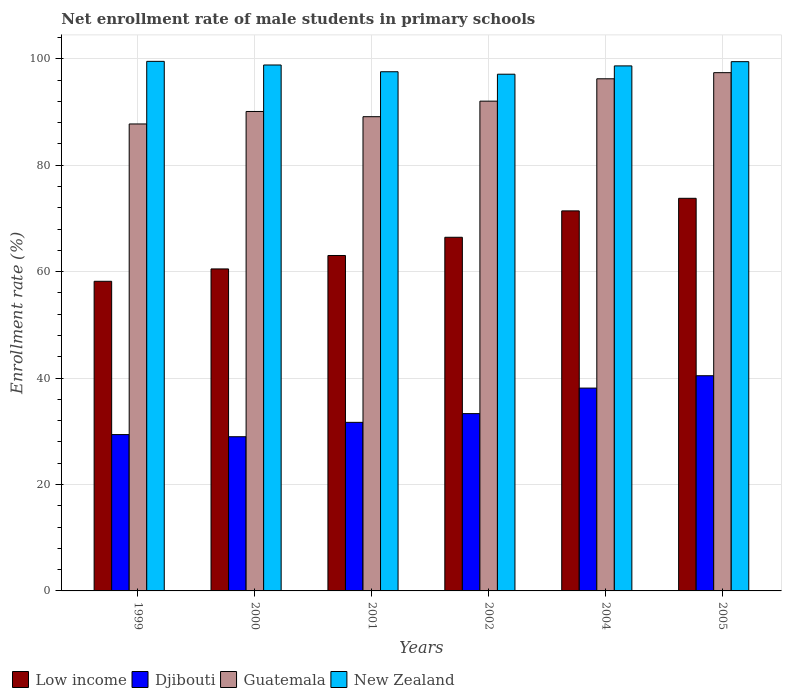How many bars are there on the 2nd tick from the right?
Give a very brief answer. 4. In how many cases, is the number of bars for a given year not equal to the number of legend labels?
Your answer should be very brief. 0. What is the net enrollment rate of male students in primary schools in Guatemala in 1999?
Your answer should be very brief. 87.76. Across all years, what is the maximum net enrollment rate of male students in primary schools in Guatemala?
Offer a terse response. 97.4. Across all years, what is the minimum net enrollment rate of male students in primary schools in Low income?
Provide a short and direct response. 58.19. In which year was the net enrollment rate of male students in primary schools in Low income minimum?
Your response must be concise. 1999. What is the total net enrollment rate of male students in primary schools in Guatemala in the graph?
Provide a succinct answer. 552.7. What is the difference between the net enrollment rate of male students in primary schools in Low income in 1999 and that in 2001?
Your answer should be compact. -4.85. What is the difference between the net enrollment rate of male students in primary schools in Guatemala in 2001 and the net enrollment rate of male students in primary schools in Low income in 2004?
Your answer should be compact. 17.7. What is the average net enrollment rate of male students in primary schools in Djibouti per year?
Offer a terse response. 33.66. In the year 2005, what is the difference between the net enrollment rate of male students in primary schools in Low income and net enrollment rate of male students in primary schools in Guatemala?
Offer a very short reply. -23.61. In how many years, is the net enrollment rate of male students in primary schools in New Zealand greater than 8 %?
Provide a short and direct response. 6. What is the ratio of the net enrollment rate of male students in primary schools in Guatemala in 2000 to that in 2001?
Your response must be concise. 1.01. What is the difference between the highest and the second highest net enrollment rate of male students in primary schools in New Zealand?
Make the answer very short. 0.06. What is the difference between the highest and the lowest net enrollment rate of male students in primary schools in Low income?
Your answer should be very brief. 15.6. Is it the case that in every year, the sum of the net enrollment rate of male students in primary schools in Guatemala and net enrollment rate of male students in primary schools in Djibouti is greater than the sum of net enrollment rate of male students in primary schools in New Zealand and net enrollment rate of male students in primary schools in Low income?
Offer a terse response. No. What does the 3rd bar from the left in 2001 represents?
Keep it short and to the point. Guatemala. Are the values on the major ticks of Y-axis written in scientific E-notation?
Keep it short and to the point. No. Does the graph contain any zero values?
Offer a very short reply. No. Does the graph contain grids?
Provide a short and direct response. Yes. What is the title of the graph?
Provide a short and direct response. Net enrollment rate of male students in primary schools. Does "Somalia" appear as one of the legend labels in the graph?
Keep it short and to the point. No. What is the label or title of the Y-axis?
Your answer should be very brief. Enrollment rate (%). What is the Enrollment rate (%) in Low income in 1999?
Your answer should be compact. 58.19. What is the Enrollment rate (%) of Djibouti in 1999?
Offer a terse response. 29.38. What is the Enrollment rate (%) of Guatemala in 1999?
Ensure brevity in your answer.  87.76. What is the Enrollment rate (%) in New Zealand in 1999?
Provide a succinct answer. 99.53. What is the Enrollment rate (%) in Low income in 2000?
Make the answer very short. 60.52. What is the Enrollment rate (%) in Djibouti in 2000?
Your answer should be compact. 28.98. What is the Enrollment rate (%) of Guatemala in 2000?
Your answer should be very brief. 90.11. What is the Enrollment rate (%) of New Zealand in 2000?
Your answer should be very brief. 98.85. What is the Enrollment rate (%) of Low income in 2001?
Offer a terse response. 63.04. What is the Enrollment rate (%) in Djibouti in 2001?
Provide a short and direct response. 31.68. What is the Enrollment rate (%) of Guatemala in 2001?
Offer a terse response. 89.13. What is the Enrollment rate (%) of New Zealand in 2001?
Provide a succinct answer. 97.58. What is the Enrollment rate (%) in Low income in 2002?
Provide a succinct answer. 66.46. What is the Enrollment rate (%) of Djibouti in 2002?
Your answer should be very brief. 33.32. What is the Enrollment rate (%) of Guatemala in 2002?
Keep it short and to the point. 92.05. What is the Enrollment rate (%) in New Zealand in 2002?
Your answer should be compact. 97.11. What is the Enrollment rate (%) in Low income in 2004?
Provide a succinct answer. 71.43. What is the Enrollment rate (%) of Djibouti in 2004?
Keep it short and to the point. 38.12. What is the Enrollment rate (%) in Guatemala in 2004?
Your answer should be very brief. 96.25. What is the Enrollment rate (%) of New Zealand in 2004?
Ensure brevity in your answer.  98.68. What is the Enrollment rate (%) of Low income in 2005?
Make the answer very short. 73.79. What is the Enrollment rate (%) in Djibouti in 2005?
Keep it short and to the point. 40.44. What is the Enrollment rate (%) in Guatemala in 2005?
Provide a succinct answer. 97.4. What is the Enrollment rate (%) of New Zealand in 2005?
Make the answer very short. 99.47. Across all years, what is the maximum Enrollment rate (%) of Low income?
Keep it short and to the point. 73.79. Across all years, what is the maximum Enrollment rate (%) of Djibouti?
Make the answer very short. 40.44. Across all years, what is the maximum Enrollment rate (%) in Guatemala?
Your response must be concise. 97.4. Across all years, what is the maximum Enrollment rate (%) in New Zealand?
Your response must be concise. 99.53. Across all years, what is the minimum Enrollment rate (%) in Low income?
Give a very brief answer. 58.19. Across all years, what is the minimum Enrollment rate (%) of Djibouti?
Your answer should be compact. 28.98. Across all years, what is the minimum Enrollment rate (%) of Guatemala?
Give a very brief answer. 87.76. Across all years, what is the minimum Enrollment rate (%) of New Zealand?
Your answer should be compact. 97.11. What is the total Enrollment rate (%) in Low income in the graph?
Offer a very short reply. 393.43. What is the total Enrollment rate (%) of Djibouti in the graph?
Your answer should be compact. 201.93. What is the total Enrollment rate (%) of Guatemala in the graph?
Your response must be concise. 552.7. What is the total Enrollment rate (%) in New Zealand in the graph?
Give a very brief answer. 591.2. What is the difference between the Enrollment rate (%) in Low income in 1999 and that in 2000?
Offer a terse response. -2.32. What is the difference between the Enrollment rate (%) in Djibouti in 1999 and that in 2000?
Provide a short and direct response. 0.4. What is the difference between the Enrollment rate (%) in Guatemala in 1999 and that in 2000?
Make the answer very short. -2.35. What is the difference between the Enrollment rate (%) in New Zealand in 1999 and that in 2000?
Ensure brevity in your answer.  0.68. What is the difference between the Enrollment rate (%) of Low income in 1999 and that in 2001?
Make the answer very short. -4.85. What is the difference between the Enrollment rate (%) in Djibouti in 1999 and that in 2001?
Provide a short and direct response. -2.3. What is the difference between the Enrollment rate (%) in Guatemala in 1999 and that in 2001?
Make the answer very short. -1.37. What is the difference between the Enrollment rate (%) in New Zealand in 1999 and that in 2001?
Your answer should be very brief. 1.95. What is the difference between the Enrollment rate (%) of Low income in 1999 and that in 2002?
Ensure brevity in your answer.  -8.27. What is the difference between the Enrollment rate (%) in Djibouti in 1999 and that in 2002?
Keep it short and to the point. -3.94. What is the difference between the Enrollment rate (%) in Guatemala in 1999 and that in 2002?
Make the answer very short. -4.29. What is the difference between the Enrollment rate (%) in New Zealand in 1999 and that in 2002?
Your response must be concise. 2.42. What is the difference between the Enrollment rate (%) of Low income in 1999 and that in 2004?
Your response must be concise. -13.23. What is the difference between the Enrollment rate (%) in Djibouti in 1999 and that in 2004?
Provide a short and direct response. -8.74. What is the difference between the Enrollment rate (%) of Guatemala in 1999 and that in 2004?
Keep it short and to the point. -8.49. What is the difference between the Enrollment rate (%) of New Zealand in 1999 and that in 2004?
Ensure brevity in your answer.  0.85. What is the difference between the Enrollment rate (%) of Low income in 1999 and that in 2005?
Your answer should be compact. -15.6. What is the difference between the Enrollment rate (%) of Djibouti in 1999 and that in 2005?
Give a very brief answer. -11.06. What is the difference between the Enrollment rate (%) in Guatemala in 1999 and that in 2005?
Your response must be concise. -9.64. What is the difference between the Enrollment rate (%) of New Zealand in 1999 and that in 2005?
Provide a short and direct response. 0.06. What is the difference between the Enrollment rate (%) in Low income in 2000 and that in 2001?
Provide a short and direct response. -2.53. What is the difference between the Enrollment rate (%) of Djibouti in 2000 and that in 2001?
Ensure brevity in your answer.  -2.7. What is the difference between the Enrollment rate (%) of Guatemala in 2000 and that in 2001?
Your response must be concise. 0.98. What is the difference between the Enrollment rate (%) in New Zealand in 2000 and that in 2001?
Keep it short and to the point. 1.27. What is the difference between the Enrollment rate (%) in Low income in 2000 and that in 2002?
Offer a terse response. -5.95. What is the difference between the Enrollment rate (%) of Djibouti in 2000 and that in 2002?
Offer a terse response. -4.34. What is the difference between the Enrollment rate (%) in Guatemala in 2000 and that in 2002?
Keep it short and to the point. -1.94. What is the difference between the Enrollment rate (%) of New Zealand in 2000 and that in 2002?
Give a very brief answer. 1.74. What is the difference between the Enrollment rate (%) of Low income in 2000 and that in 2004?
Ensure brevity in your answer.  -10.91. What is the difference between the Enrollment rate (%) of Djibouti in 2000 and that in 2004?
Provide a succinct answer. -9.14. What is the difference between the Enrollment rate (%) of Guatemala in 2000 and that in 2004?
Keep it short and to the point. -6.14. What is the difference between the Enrollment rate (%) of New Zealand in 2000 and that in 2004?
Offer a terse response. 0.17. What is the difference between the Enrollment rate (%) in Low income in 2000 and that in 2005?
Keep it short and to the point. -13.27. What is the difference between the Enrollment rate (%) of Djibouti in 2000 and that in 2005?
Offer a very short reply. -11.46. What is the difference between the Enrollment rate (%) in Guatemala in 2000 and that in 2005?
Make the answer very short. -7.3. What is the difference between the Enrollment rate (%) of New Zealand in 2000 and that in 2005?
Provide a succinct answer. -0.62. What is the difference between the Enrollment rate (%) in Low income in 2001 and that in 2002?
Your answer should be very brief. -3.42. What is the difference between the Enrollment rate (%) in Djibouti in 2001 and that in 2002?
Your answer should be compact. -1.64. What is the difference between the Enrollment rate (%) in Guatemala in 2001 and that in 2002?
Keep it short and to the point. -2.92. What is the difference between the Enrollment rate (%) of New Zealand in 2001 and that in 2002?
Offer a very short reply. 0.46. What is the difference between the Enrollment rate (%) in Low income in 2001 and that in 2004?
Make the answer very short. -8.38. What is the difference between the Enrollment rate (%) in Djibouti in 2001 and that in 2004?
Ensure brevity in your answer.  -6.44. What is the difference between the Enrollment rate (%) of Guatemala in 2001 and that in 2004?
Offer a terse response. -7.12. What is the difference between the Enrollment rate (%) in New Zealand in 2001 and that in 2004?
Your answer should be compact. -1.1. What is the difference between the Enrollment rate (%) of Low income in 2001 and that in 2005?
Make the answer very short. -10.75. What is the difference between the Enrollment rate (%) in Djibouti in 2001 and that in 2005?
Your answer should be very brief. -8.76. What is the difference between the Enrollment rate (%) in Guatemala in 2001 and that in 2005?
Make the answer very short. -8.27. What is the difference between the Enrollment rate (%) of New Zealand in 2001 and that in 2005?
Ensure brevity in your answer.  -1.89. What is the difference between the Enrollment rate (%) in Low income in 2002 and that in 2004?
Provide a succinct answer. -4.96. What is the difference between the Enrollment rate (%) in Djibouti in 2002 and that in 2004?
Give a very brief answer. -4.8. What is the difference between the Enrollment rate (%) in Guatemala in 2002 and that in 2004?
Offer a terse response. -4.2. What is the difference between the Enrollment rate (%) of New Zealand in 2002 and that in 2004?
Ensure brevity in your answer.  -1.56. What is the difference between the Enrollment rate (%) of Low income in 2002 and that in 2005?
Give a very brief answer. -7.33. What is the difference between the Enrollment rate (%) of Djibouti in 2002 and that in 2005?
Provide a succinct answer. -7.12. What is the difference between the Enrollment rate (%) in Guatemala in 2002 and that in 2005?
Make the answer very short. -5.35. What is the difference between the Enrollment rate (%) of New Zealand in 2002 and that in 2005?
Ensure brevity in your answer.  -2.36. What is the difference between the Enrollment rate (%) of Low income in 2004 and that in 2005?
Your answer should be compact. -2.37. What is the difference between the Enrollment rate (%) in Djibouti in 2004 and that in 2005?
Offer a terse response. -2.32. What is the difference between the Enrollment rate (%) of Guatemala in 2004 and that in 2005?
Your response must be concise. -1.15. What is the difference between the Enrollment rate (%) in New Zealand in 2004 and that in 2005?
Provide a succinct answer. -0.79. What is the difference between the Enrollment rate (%) in Low income in 1999 and the Enrollment rate (%) in Djibouti in 2000?
Ensure brevity in your answer.  29.21. What is the difference between the Enrollment rate (%) of Low income in 1999 and the Enrollment rate (%) of Guatemala in 2000?
Offer a very short reply. -31.91. What is the difference between the Enrollment rate (%) in Low income in 1999 and the Enrollment rate (%) in New Zealand in 2000?
Keep it short and to the point. -40.65. What is the difference between the Enrollment rate (%) of Djibouti in 1999 and the Enrollment rate (%) of Guatemala in 2000?
Offer a terse response. -60.72. What is the difference between the Enrollment rate (%) of Djibouti in 1999 and the Enrollment rate (%) of New Zealand in 2000?
Your answer should be very brief. -69.46. What is the difference between the Enrollment rate (%) of Guatemala in 1999 and the Enrollment rate (%) of New Zealand in 2000?
Your response must be concise. -11.08. What is the difference between the Enrollment rate (%) in Low income in 1999 and the Enrollment rate (%) in Djibouti in 2001?
Make the answer very short. 26.51. What is the difference between the Enrollment rate (%) in Low income in 1999 and the Enrollment rate (%) in Guatemala in 2001?
Ensure brevity in your answer.  -30.93. What is the difference between the Enrollment rate (%) in Low income in 1999 and the Enrollment rate (%) in New Zealand in 2001?
Your answer should be very brief. -39.38. What is the difference between the Enrollment rate (%) in Djibouti in 1999 and the Enrollment rate (%) in Guatemala in 2001?
Your answer should be very brief. -59.75. What is the difference between the Enrollment rate (%) in Djibouti in 1999 and the Enrollment rate (%) in New Zealand in 2001?
Your response must be concise. -68.19. What is the difference between the Enrollment rate (%) in Guatemala in 1999 and the Enrollment rate (%) in New Zealand in 2001?
Your response must be concise. -9.81. What is the difference between the Enrollment rate (%) in Low income in 1999 and the Enrollment rate (%) in Djibouti in 2002?
Provide a short and direct response. 24.87. What is the difference between the Enrollment rate (%) in Low income in 1999 and the Enrollment rate (%) in Guatemala in 2002?
Your response must be concise. -33.86. What is the difference between the Enrollment rate (%) of Low income in 1999 and the Enrollment rate (%) of New Zealand in 2002?
Your answer should be compact. -38.92. What is the difference between the Enrollment rate (%) of Djibouti in 1999 and the Enrollment rate (%) of Guatemala in 2002?
Provide a short and direct response. -62.67. What is the difference between the Enrollment rate (%) of Djibouti in 1999 and the Enrollment rate (%) of New Zealand in 2002?
Your answer should be compact. -67.73. What is the difference between the Enrollment rate (%) in Guatemala in 1999 and the Enrollment rate (%) in New Zealand in 2002?
Offer a terse response. -9.35. What is the difference between the Enrollment rate (%) in Low income in 1999 and the Enrollment rate (%) in Djibouti in 2004?
Give a very brief answer. 20.07. What is the difference between the Enrollment rate (%) of Low income in 1999 and the Enrollment rate (%) of Guatemala in 2004?
Your answer should be compact. -38.06. What is the difference between the Enrollment rate (%) of Low income in 1999 and the Enrollment rate (%) of New Zealand in 2004?
Provide a short and direct response. -40.48. What is the difference between the Enrollment rate (%) of Djibouti in 1999 and the Enrollment rate (%) of Guatemala in 2004?
Your answer should be compact. -66.87. What is the difference between the Enrollment rate (%) in Djibouti in 1999 and the Enrollment rate (%) in New Zealand in 2004?
Your response must be concise. -69.29. What is the difference between the Enrollment rate (%) in Guatemala in 1999 and the Enrollment rate (%) in New Zealand in 2004?
Keep it short and to the point. -10.91. What is the difference between the Enrollment rate (%) in Low income in 1999 and the Enrollment rate (%) in Djibouti in 2005?
Offer a terse response. 17.75. What is the difference between the Enrollment rate (%) in Low income in 1999 and the Enrollment rate (%) in Guatemala in 2005?
Your answer should be very brief. -39.21. What is the difference between the Enrollment rate (%) of Low income in 1999 and the Enrollment rate (%) of New Zealand in 2005?
Your answer should be very brief. -41.28. What is the difference between the Enrollment rate (%) in Djibouti in 1999 and the Enrollment rate (%) in Guatemala in 2005?
Offer a very short reply. -68.02. What is the difference between the Enrollment rate (%) in Djibouti in 1999 and the Enrollment rate (%) in New Zealand in 2005?
Your answer should be compact. -70.09. What is the difference between the Enrollment rate (%) of Guatemala in 1999 and the Enrollment rate (%) of New Zealand in 2005?
Offer a very short reply. -11.71. What is the difference between the Enrollment rate (%) of Low income in 2000 and the Enrollment rate (%) of Djibouti in 2001?
Provide a succinct answer. 28.84. What is the difference between the Enrollment rate (%) of Low income in 2000 and the Enrollment rate (%) of Guatemala in 2001?
Give a very brief answer. -28.61. What is the difference between the Enrollment rate (%) in Low income in 2000 and the Enrollment rate (%) in New Zealand in 2001?
Keep it short and to the point. -37.06. What is the difference between the Enrollment rate (%) of Djibouti in 2000 and the Enrollment rate (%) of Guatemala in 2001?
Provide a short and direct response. -60.15. What is the difference between the Enrollment rate (%) in Djibouti in 2000 and the Enrollment rate (%) in New Zealand in 2001?
Provide a succinct answer. -68.6. What is the difference between the Enrollment rate (%) in Guatemala in 2000 and the Enrollment rate (%) in New Zealand in 2001?
Provide a short and direct response. -7.47. What is the difference between the Enrollment rate (%) in Low income in 2000 and the Enrollment rate (%) in Djibouti in 2002?
Provide a short and direct response. 27.19. What is the difference between the Enrollment rate (%) of Low income in 2000 and the Enrollment rate (%) of Guatemala in 2002?
Offer a terse response. -31.53. What is the difference between the Enrollment rate (%) in Low income in 2000 and the Enrollment rate (%) in New Zealand in 2002?
Give a very brief answer. -36.59. What is the difference between the Enrollment rate (%) of Djibouti in 2000 and the Enrollment rate (%) of Guatemala in 2002?
Make the answer very short. -63.07. What is the difference between the Enrollment rate (%) in Djibouti in 2000 and the Enrollment rate (%) in New Zealand in 2002?
Keep it short and to the point. -68.13. What is the difference between the Enrollment rate (%) in Guatemala in 2000 and the Enrollment rate (%) in New Zealand in 2002?
Make the answer very short. -7. What is the difference between the Enrollment rate (%) in Low income in 2000 and the Enrollment rate (%) in Djibouti in 2004?
Give a very brief answer. 22.39. What is the difference between the Enrollment rate (%) in Low income in 2000 and the Enrollment rate (%) in Guatemala in 2004?
Offer a very short reply. -35.73. What is the difference between the Enrollment rate (%) in Low income in 2000 and the Enrollment rate (%) in New Zealand in 2004?
Offer a terse response. -38.16. What is the difference between the Enrollment rate (%) of Djibouti in 2000 and the Enrollment rate (%) of Guatemala in 2004?
Make the answer very short. -67.27. What is the difference between the Enrollment rate (%) of Djibouti in 2000 and the Enrollment rate (%) of New Zealand in 2004?
Ensure brevity in your answer.  -69.7. What is the difference between the Enrollment rate (%) of Guatemala in 2000 and the Enrollment rate (%) of New Zealand in 2004?
Provide a succinct answer. -8.57. What is the difference between the Enrollment rate (%) in Low income in 2000 and the Enrollment rate (%) in Djibouti in 2005?
Provide a succinct answer. 20.07. What is the difference between the Enrollment rate (%) of Low income in 2000 and the Enrollment rate (%) of Guatemala in 2005?
Your answer should be compact. -36.89. What is the difference between the Enrollment rate (%) of Low income in 2000 and the Enrollment rate (%) of New Zealand in 2005?
Offer a very short reply. -38.95. What is the difference between the Enrollment rate (%) in Djibouti in 2000 and the Enrollment rate (%) in Guatemala in 2005?
Provide a succinct answer. -68.42. What is the difference between the Enrollment rate (%) in Djibouti in 2000 and the Enrollment rate (%) in New Zealand in 2005?
Ensure brevity in your answer.  -70.49. What is the difference between the Enrollment rate (%) of Guatemala in 2000 and the Enrollment rate (%) of New Zealand in 2005?
Your answer should be very brief. -9.36. What is the difference between the Enrollment rate (%) of Low income in 2001 and the Enrollment rate (%) of Djibouti in 2002?
Give a very brief answer. 29.72. What is the difference between the Enrollment rate (%) of Low income in 2001 and the Enrollment rate (%) of Guatemala in 2002?
Your answer should be compact. -29.01. What is the difference between the Enrollment rate (%) of Low income in 2001 and the Enrollment rate (%) of New Zealand in 2002?
Your answer should be compact. -34.07. What is the difference between the Enrollment rate (%) in Djibouti in 2001 and the Enrollment rate (%) in Guatemala in 2002?
Make the answer very short. -60.37. What is the difference between the Enrollment rate (%) in Djibouti in 2001 and the Enrollment rate (%) in New Zealand in 2002?
Keep it short and to the point. -65.43. What is the difference between the Enrollment rate (%) of Guatemala in 2001 and the Enrollment rate (%) of New Zealand in 2002?
Your answer should be compact. -7.98. What is the difference between the Enrollment rate (%) of Low income in 2001 and the Enrollment rate (%) of Djibouti in 2004?
Give a very brief answer. 24.92. What is the difference between the Enrollment rate (%) in Low income in 2001 and the Enrollment rate (%) in Guatemala in 2004?
Ensure brevity in your answer.  -33.21. What is the difference between the Enrollment rate (%) of Low income in 2001 and the Enrollment rate (%) of New Zealand in 2004?
Ensure brevity in your answer.  -35.63. What is the difference between the Enrollment rate (%) in Djibouti in 2001 and the Enrollment rate (%) in Guatemala in 2004?
Your answer should be compact. -64.57. What is the difference between the Enrollment rate (%) in Djibouti in 2001 and the Enrollment rate (%) in New Zealand in 2004?
Offer a terse response. -67. What is the difference between the Enrollment rate (%) in Guatemala in 2001 and the Enrollment rate (%) in New Zealand in 2004?
Provide a short and direct response. -9.55. What is the difference between the Enrollment rate (%) in Low income in 2001 and the Enrollment rate (%) in Djibouti in 2005?
Provide a succinct answer. 22.6. What is the difference between the Enrollment rate (%) of Low income in 2001 and the Enrollment rate (%) of Guatemala in 2005?
Offer a very short reply. -34.36. What is the difference between the Enrollment rate (%) in Low income in 2001 and the Enrollment rate (%) in New Zealand in 2005?
Ensure brevity in your answer.  -36.43. What is the difference between the Enrollment rate (%) of Djibouti in 2001 and the Enrollment rate (%) of Guatemala in 2005?
Make the answer very short. -65.72. What is the difference between the Enrollment rate (%) of Djibouti in 2001 and the Enrollment rate (%) of New Zealand in 2005?
Offer a terse response. -67.79. What is the difference between the Enrollment rate (%) in Guatemala in 2001 and the Enrollment rate (%) in New Zealand in 2005?
Offer a very short reply. -10.34. What is the difference between the Enrollment rate (%) in Low income in 2002 and the Enrollment rate (%) in Djibouti in 2004?
Offer a very short reply. 28.34. What is the difference between the Enrollment rate (%) of Low income in 2002 and the Enrollment rate (%) of Guatemala in 2004?
Your answer should be compact. -29.79. What is the difference between the Enrollment rate (%) in Low income in 2002 and the Enrollment rate (%) in New Zealand in 2004?
Offer a very short reply. -32.21. What is the difference between the Enrollment rate (%) of Djibouti in 2002 and the Enrollment rate (%) of Guatemala in 2004?
Give a very brief answer. -62.93. What is the difference between the Enrollment rate (%) in Djibouti in 2002 and the Enrollment rate (%) in New Zealand in 2004?
Offer a terse response. -65.35. What is the difference between the Enrollment rate (%) of Guatemala in 2002 and the Enrollment rate (%) of New Zealand in 2004?
Your response must be concise. -6.63. What is the difference between the Enrollment rate (%) of Low income in 2002 and the Enrollment rate (%) of Djibouti in 2005?
Provide a short and direct response. 26.02. What is the difference between the Enrollment rate (%) in Low income in 2002 and the Enrollment rate (%) in Guatemala in 2005?
Make the answer very short. -30.94. What is the difference between the Enrollment rate (%) in Low income in 2002 and the Enrollment rate (%) in New Zealand in 2005?
Provide a short and direct response. -33. What is the difference between the Enrollment rate (%) of Djibouti in 2002 and the Enrollment rate (%) of Guatemala in 2005?
Give a very brief answer. -64.08. What is the difference between the Enrollment rate (%) in Djibouti in 2002 and the Enrollment rate (%) in New Zealand in 2005?
Give a very brief answer. -66.15. What is the difference between the Enrollment rate (%) in Guatemala in 2002 and the Enrollment rate (%) in New Zealand in 2005?
Keep it short and to the point. -7.42. What is the difference between the Enrollment rate (%) in Low income in 2004 and the Enrollment rate (%) in Djibouti in 2005?
Offer a very short reply. 30.98. What is the difference between the Enrollment rate (%) of Low income in 2004 and the Enrollment rate (%) of Guatemala in 2005?
Offer a very short reply. -25.98. What is the difference between the Enrollment rate (%) in Low income in 2004 and the Enrollment rate (%) in New Zealand in 2005?
Your answer should be very brief. -28.04. What is the difference between the Enrollment rate (%) of Djibouti in 2004 and the Enrollment rate (%) of Guatemala in 2005?
Your answer should be compact. -59.28. What is the difference between the Enrollment rate (%) in Djibouti in 2004 and the Enrollment rate (%) in New Zealand in 2005?
Give a very brief answer. -61.35. What is the difference between the Enrollment rate (%) of Guatemala in 2004 and the Enrollment rate (%) of New Zealand in 2005?
Your answer should be compact. -3.22. What is the average Enrollment rate (%) of Low income per year?
Offer a very short reply. 65.57. What is the average Enrollment rate (%) in Djibouti per year?
Make the answer very short. 33.66. What is the average Enrollment rate (%) of Guatemala per year?
Your answer should be compact. 92.12. What is the average Enrollment rate (%) in New Zealand per year?
Offer a terse response. 98.53. In the year 1999, what is the difference between the Enrollment rate (%) of Low income and Enrollment rate (%) of Djibouti?
Keep it short and to the point. 28.81. In the year 1999, what is the difference between the Enrollment rate (%) in Low income and Enrollment rate (%) in Guatemala?
Offer a terse response. -29.57. In the year 1999, what is the difference between the Enrollment rate (%) of Low income and Enrollment rate (%) of New Zealand?
Offer a very short reply. -41.33. In the year 1999, what is the difference between the Enrollment rate (%) of Djibouti and Enrollment rate (%) of Guatemala?
Give a very brief answer. -58.38. In the year 1999, what is the difference between the Enrollment rate (%) in Djibouti and Enrollment rate (%) in New Zealand?
Your response must be concise. -70.15. In the year 1999, what is the difference between the Enrollment rate (%) of Guatemala and Enrollment rate (%) of New Zealand?
Ensure brevity in your answer.  -11.77. In the year 2000, what is the difference between the Enrollment rate (%) in Low income and Enrollment rate (%) in Djibouti?
Provide a succinct answer. 31.54. In the year 2000, what is the difference between the Enrollment rate (%) in Low income and Enrollment rate (%) in Guatemala?
Make the answer very short. -29.59. In the year 2000, what is the difference between the Enrollment rate (%) in Low income and Enrollment rate (%) in New Zealand?
Provide a succinct answer. -38.33. In the year 2000, what is the difference between the Enrollment rate (%) of Djibouti and Enrollment rate (%) of Guatemala?
Offer a very short reply. -61.13. In the year 2000, what is the difference between the Enrollment rate (%) in Djibouti and Enrollment rate (%) in New Zealand?
Provide a succinct answer. -69.87. In the year 2000, what is the difference between the Enrollment rate (%) of Guatemala and Enrollment rate (%) of New Zealand?
Offer a terse response. -8.74. In the year 2001, what is the difference between the Enrollment rate (%) of Low income and Enrollment rate (%) of Djibouti?
Your answer should be very brief. 31.36. In the year 2001, what is the difference between the Enrollment rate (%) of Low income and Enrollment rate (%) of Guatemala?
Give a very brief answer. -26.09. In the year 2001, what is the difference between the Enrollment rate (%) in Low income and Enrollment rate (%) in New Zealand?
Your answer should be compact. -34.53. In the year 2001, what is the difference between the Enrollment rate (%) in Djibouti and Enrollment rate (%) in Guatemala?
Keep it short and to the point. -57.45. In the year 2001, what is the difference between the Enrollment rate (%) in Djibouti and Enrollment rate (%) in New Zealand?
Your response must be concise. -65.9. In the year 2001, what is the difference between the Enrollment rate (%) in Guatemala and Enrollment rate (%) in New Zealand?
Your response must be concise. -8.45. In the year 2002, what is the difference between the Enrollment rate (%) in Low income and Enrollment rate (%) in Djibouti?
Ensure brevity in your answer.  33.14. In the year 2002, what is the difference between the Enrollment rate (%) in Low income and Enrollment rate (%) in Guatemala?
Your answer should be compact. -25.58. In the year 2002, what is the difference between the Enrollment rate (%) in Low income and Enrollment rate (%) in New Zealand?
Provide a short and direct response. -30.65. In the year 2002, what is the difference between the Enrollment rate (%) in Djibouti and Enrollment rate (%) in Guatemala?
Ensure brevity in your answer.  -58.73. In the year 2002, what is the difference between the Enrollment rate (%) in Djibouti and Enrollment rate (%) in New Zealand?
Offer a terse response. -63.79. In the year 2002, what is the difference between the Enrollment rate (%) of Guatemala and Enrollment rate (%) of New Zealand?
Your response must be concise. -5.06. In the year 2004, what is the difference between the Enrollment rate (%) of Low income and Enrollment rate (%) of Djibouti?
Offer a very short reply. 33.3. In the year 2004, what is the difference between the Enrollment rate (%) in Low income and Enrollment rate (%) in Guatemala?
Your answer should be very brief. -24.83. In the year 2004, what is the difference between the Enrollment rate (%) in Low income and Enrollment rate (%) in New Zealand?
Make the answer very short. -27.25. In the year 2004, what is the difference between the Enrollment rate (%) of Djibouti and Enrollment rate (%) of Guatemala?
Keep it short and to the point. -58.13. In the year 2004, what is the difference between the Enrollment rate (%) of Djibouti and Enrollment rate (%) of New Zealand?
Your answer should be compact. -60.55. In the year 2004, what is the difference between the Enrollment rate (%) of Guatemala and Enrollment rate (%) of New Zealand?
Make the answer very short. -2.43. In the year 2005, what is the difference between the Enrollment rate (%) in Low income and Enrollment rate (%) in Djibouti?
Make the answer very short. 33.35. In the year 2005, what is the difference between the Enrollment rate (%) in Low income and Enrollment rate (%) in Guatemala?
Ensure brevity in your answer.  -23.61. In the year 2005, what is the difference between the Enrollment rate (%) in Low income and Enrollment rate (%) in New Zealand?
Keep it short and to the point. -25.68. In the year 2005, what is the difference between the Enrollment rate (%) in Djibouti and Enrollment rate (%) in Guatemala?
Provide a succinct answer. -56.96. In the year 2005, what is the difference between the Enrollment rate (%) in Djibouti and Enrollment rate (%) in New Zealand?
Provide a succinct answer. -59.02. In the year 2005, what is the difference between the Enrollment rate (%) of Guatemala and Enrollment rate (%) of New Zealand?
Keep it short and to the point. -2.07. What is the ratio of the Enrollment rate (%) in Low income in 1999 to that in 2000?
Your response must be concise. 0.96. What is the ratio of the Enrollment rate (%) of Djibouti in 1999 to that in 2000?
Make the answer very short. 1.01. What is the ratio of the Enrollment rate (%) of Guatemala in 1999 to that in 2000?
Ensure brevity in your answer.  0.97. What is the ratio of the Enrollment rate (%) of Djibouti in 1999 to that in 2001?
Keep it short and to the point. 0.93. What is the ratio of the Enrollment rate (%) in Guatemala in 1999 to that in 2001?
Make the answer very short. 0.98. What is the ratio of the Enrollment rate (%) in Low income in 1999 to that in 2002?
Your response must be concise. 0.88. What is the ratio of the Enrollment rate (%) in Djibouti in 1999 to that in 2002?
Keep it short and to the point. 0.88. What is the ratio of the Enrollment rate (%) in Guatemala in 1999 to that in 2002?
Your response must be concise. 0.95. What is the ratio of the Enrollment rate (%) of New Zealand in 1999 to that in 2002?
Provide a short and direct response. 1.02. What is the ratio of the Enrollment rate (%) in Low income in 1999 to that in 2004?
Offer a terse response. 0.81. What is the ratio of the Enrollment rate (%) in Djibouti in 1999 to that in 2004?
Ensure brevity in your answer.  0.77. What is the ratio of the Enrollment rate (%) of Guatemala in 1999 to that in 2004?
Offer a terse response. 0.91. What is the ratio of the Enrollment rate (%) in New Zealand in 1999 to that in 2004?
Your answer should be compact. 1.01. What is the ratio of the Enrollment rate (%) in Low income in 1999 to that in 2005?
Ensure brevity in your answer.  0.79. What is the ratio of the Enrollment rate (%) of Djibouti in 1999 to that in 2005?
Provide a succinct answer. 0.73. What is the ratio of the Enrollment rate (%) of Guatemala in 1999 to that in 2005?
Provide a succinct answer. 0.9. What is the ratio of the Enrollment rate (%) of New Zealand in 1999 to that in 2005?
Your answer should be very brief. 1. What is the ratio of the Enrollment rate (%) of Low income in 2000 to that in 2001?
Offer a terse response. 0.96. What is the ratio of the Enrollment rate (%) of Djibouti in 2000 to that in 2001?
Ensure brevity in your answer.  0.91. What is the ratio of the Enrollment rate (%) in Guatemala in 2000 to that in 2001?
Make the answer very short. 1.01. What is the ratio of the Enrollment rate (%) in New Zealand in 2000 to that in 2001?
Your answer should be compact. 1.01. What is the ratio of the Enrollment rate (%) in Low income in 2000 to that in 2002?
Ensure brevity in your answer.  0.91. What is the ratio of the Enrollment rate (%) of Djibouti in 2000 to that in 2002?
Offer a very short reply. 0.87. What is the ratio of the Enrollment rate (%) in Guatemala in 2000 to that in 2002?
Keep it short and to the point. 0.98. What is the ratio of the Enrollment rate (%) in New Zealand in 2000 to that in 2002?
Provide a short and direct response. 1.02. What is the ratio of the Enrollment rate (%) of Low income in 2000 to that in 2004?
Give a very brief answer. 0.85. What is the ratio of the Enrollment rate (%) of Djibouti in 2000 to that in 2004?
Ensure brevity in your answer.  0.76. What is the ratio of the Enrollment rate (%) of Guatemala in 2000 to that in 2004?
Make the answer very short. 0.94. What is the ratio of the Enrollment rate (%) of Low income in 2000 to that in 2005?
Ensure brevity in your answer.  0.82. What is the ratio of the Enrollment rate (%) of Djibouti in 2000 to that in 2005?
Keep it short and to the point. 0.72. What is the ratio of the Enrollment rate (%) of Guatemala in 2000 to that in 2005?
Provide a short and direct response. 0.93. What is the ratio of the Enrollment rate (%) of Low income in 2001 to that in 2002?
Provide a succinct answer. 0.95. What is the ratio of the Enrollment rate (%) of Djibouti in 2001 to that in 2002?
Keep it short and to the point. 0.95. What is the ratio of the Enrollment rate (%) of Guatemala in 2001 to that in 2002?
Provide a short and direct response. 0.97. What is the ratio of the Enrollment rate (%) in Low income in 2001 to that in 2004?
Give a very brief answer. 0.88. What is the ratio of the Enrollment rate (%) of Djibouti in 2001 to that in 2004?
Your answer should be compact. 0.83. What is the ratio of the Enrollment rate (%) in Guatemala in 2001 to that in 2004?
Give a very brief answer. 0.93. What is the ratio of the Enrollment rate (%) in New Zealand in 2001 to that in 2004?
Your answer should be compact. 0.99. What is the ratio of the Enrollment rate (%) of Low income in 2001 to that in 2005?
Your response must be concise. 0.85. What is the ratio of the Enrollment rate (%) of Djibouti in 2001 to that in 2005?
Offer a terse response. 0.78. What is the ratio of the Enrollment rate (%) in Guatemala in 2001 to that in 2005?
Your answer should be compact. 0.92. What is the ratio of the Enrollment rate (%) of New Zealand in 2001 to that in 2005?
Your response must be concise. 0.98. What is the ratio of the Enrollment rate (%) of Low income in 2002 to that in 2004?
Offer a very short reply. 0.93. What is the ratio of the Enrollment rate (%) in Djibouti in 2002 to that in 2004?
Offer a very short reply. 0.87. What is the ratio of the Enrollment rate (%) in Guatemala in 2002 to that in 2004?
Offer a very short reply. 0.96. What is the ratio of the Enrollment rate (%) in New Zealand in 2002 to that in 2004?
Offer a terse response. 0.98. What is the ratio of the Enrollment rate (%) of Low income in 2002 to that in 2005?
Keep it short and to the point. 0.9. What is the ratio of the Enrollment rate (%) in Djibouti in 2002 to that in 2005?
Keep it short and to the point. 0.82. What is the ratio of the Enrollment rate (%) in Guatemala in 2002 to that in 2005?
Your response must be concise. 0.94. What is the ratio of the Enrollment rate (%) of New Zealand in 2002 to that in 2005?
Provide a short and direct response. 0.98. What is the ratio of the Enrollment rate (%) in Low income in 2004 to that in 2005?
Your answer should be compact. 0.97. What is the ratio of the Enrollment rate (%) in Djibouti in 2004 to that in 2005?
Your response must be concise. 0.94. What is the ratio of the Enrollment rate (%) in Guatemala in 2004 to that in 2005?
Offer a very short reply. 0.99. What is the difference between the highest and the second highest Enrollment rate (%) in Low income?
Provide a succinct answer. 2.37. What is the difference between the highest and the second highest Enrollment rate (%) of Djibouti?
Provide a short and direct response. 2.32. What is the difference between the highest and the second highest Enrollment rate (%) of Guatemala?
Your answer should be compact. 1.15. What is the difference between the highest and the second highest Enrollment rate (%) in New Zealand?
Offer a terse response. 0.06. What is the difference between the highest and the lowest Enrollment rate (%) in Low income?
Give a very brief answer. 15.6. What is the difference between the highest and the lowest Enrollment rate (%) in Djibouti?
Your answer should be very brief. 11.46. What is the difference between the highest and the lowest Enrollment rate (%) in Guatemala?
Offer a very short reply. 9.64. What is the difference between the highest and the lowest Enrollment rate (%) of New Zealand?
Offer a terse response. 2.42. 